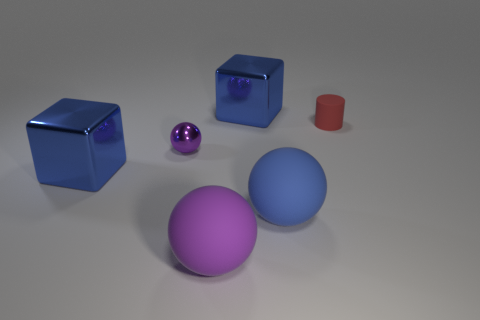Add 5 purple objects. How many purple objects are left? 7 Add 2 cubes. How many cubes exist? 4 Add 1 small gray metal blocks. How many objects exist? 7 Subtract all purple spheres. How many spheres are left? 1 Subtract all big matte spheres. How many spheres are left? 1 Subtract 1 blue blocks. How many objects are left? 5 Subtract all cylinders. How many objects are left? 5 Subtract 3 balls. How many balls are left? 0 Subtract all blue spheres. Subtract all blue blocks. How many spheres are left? 2 Subtract all gray blocks. How many yellow cylinders are left? 0 